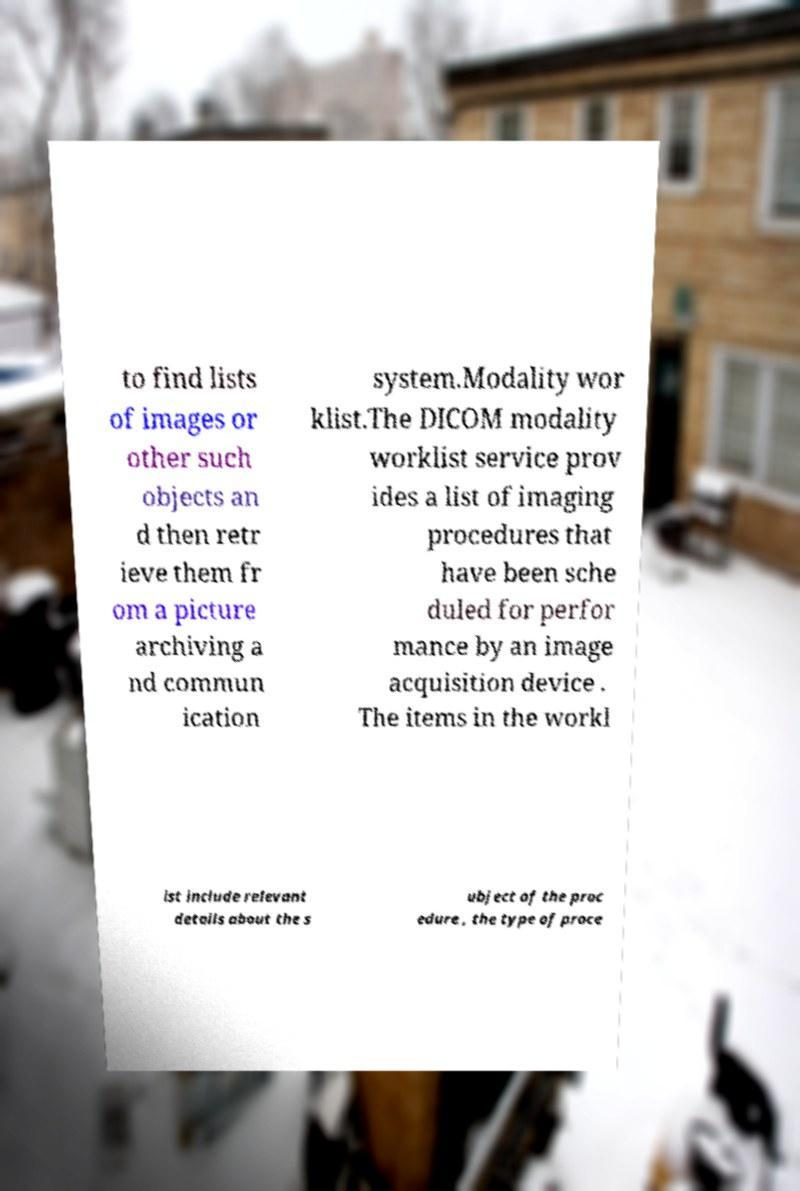Please read and relay the text visible in this image. What does it say? to find lists of images or other such objects an d then retr ieve them fr om a picture archiving a nd commun ication system.Modality wor klist.The DICOM modality worklist service prov ides a list of imaging procedures that have been sche duled for perfor mance by an image acquisition device . The items in the workl ist include relevant details about the s ubject of the proc edure , the type of proce 